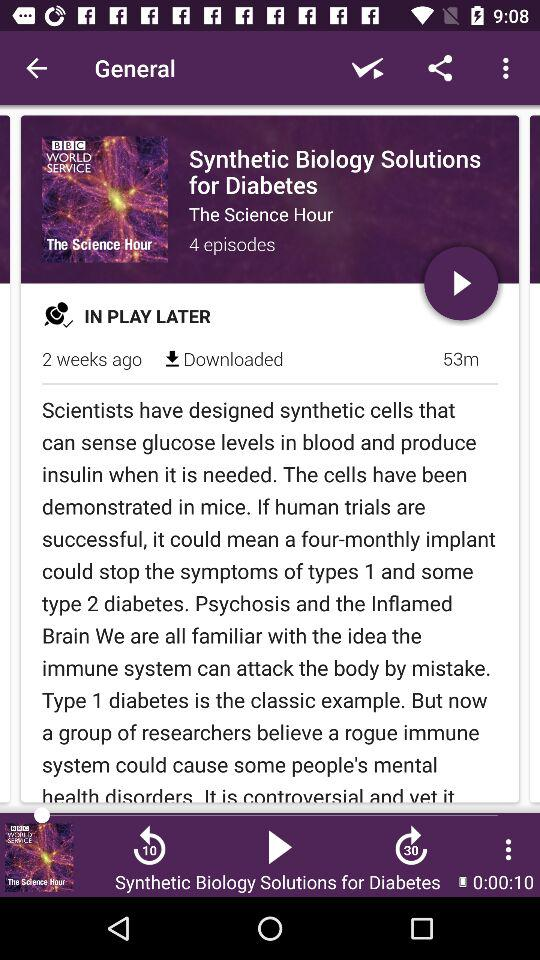What is the duration of the video? The duration of the video is 53 minutes. 